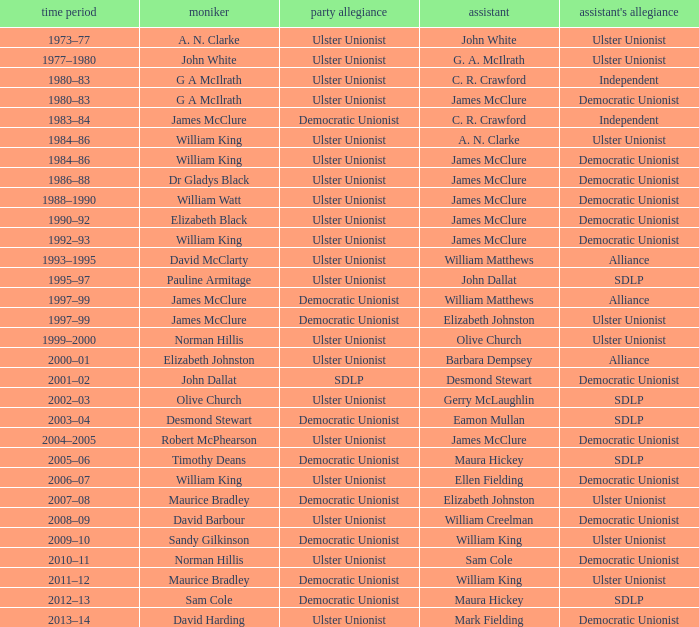What is the Name for 1997–99? James McClure, James McClure. 